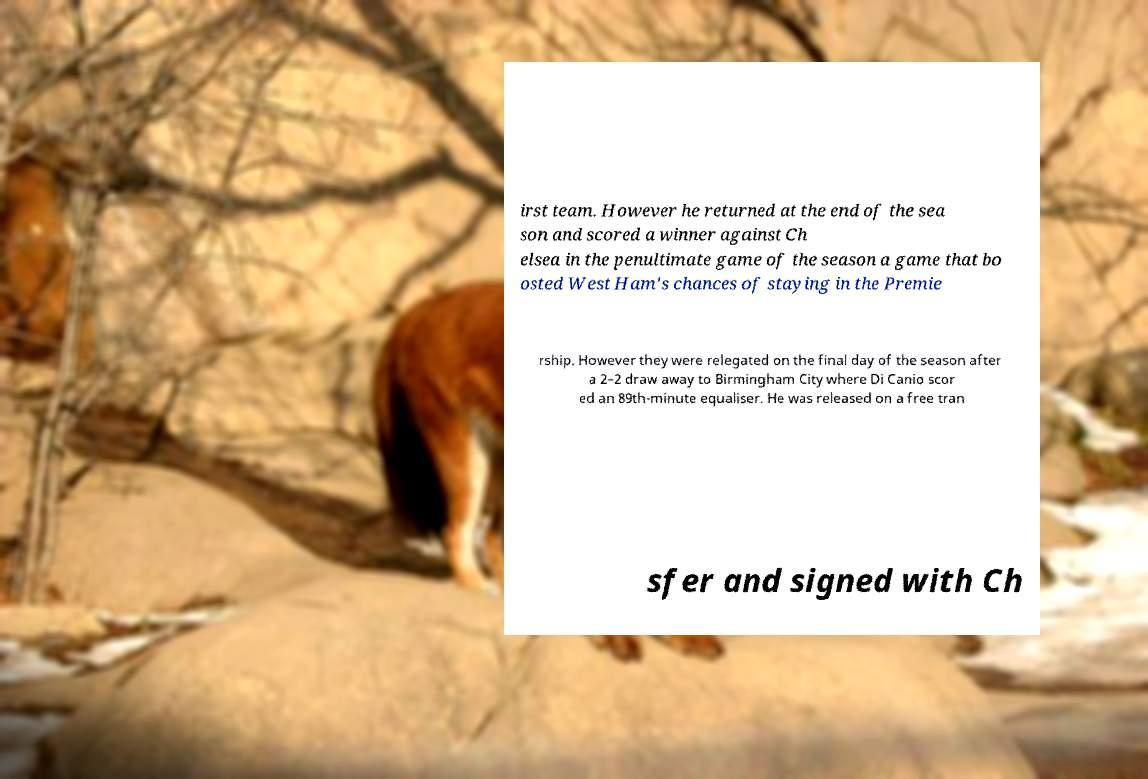What messages or text are displayed in this image? I need them in a readable, typed format. irst team. However he returned at the end of the sea son and scored a winner against Ch elsea in the penultimate game of the season a game that bo osted West Ham's chances of staying in the Premie rship. However they were relegated on the final day of the season after a 2–2 draw away to Birmingham City where Di Canio scor ed an 89th-minute equaliser. He was released on a free tran sfer and signed with Ch 